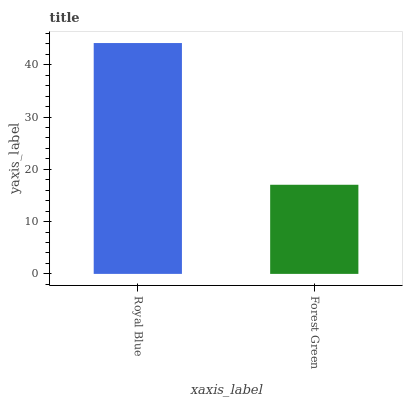Is Forest Green the minimum?
Answer yes or no. Yes. Is Royal Blue the maximum?
Answer yes or no. Yes. Is Forest Green the maximum?
Answer yes or no. No. Is Royal Blue greater than Forest Green?
Answer yes or no. Yes. Is Forest Green less than Royal Blue?
Answer yes or no. Yes. Is Forest Green greater than Royal Blue?
Answer yes or no. No. Is Royal Blue less than Forest Green?
Answer yes or no. No. Is Royal Blue the high median?
Answer yes or no. Yes. Is Forest Green the low median?
Answer yes or no. Yes. Is Forest Green the high median?
Answer yes or no. No. Is Royal Blue the low median?
Answer yes or no. No. 